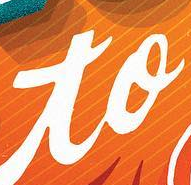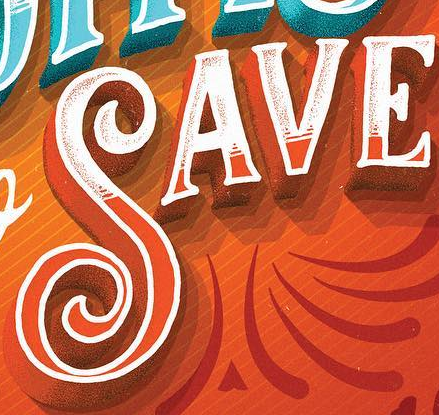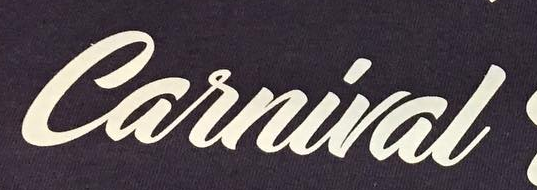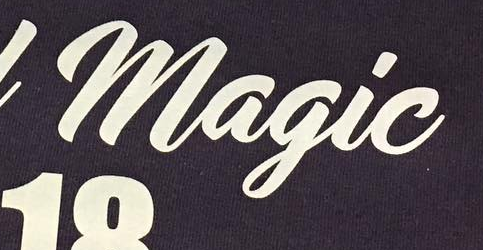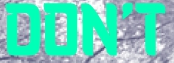What words are shown in these images in order, separated by a semicolon? to; SAVE; Carnival; Magic; DON'T 